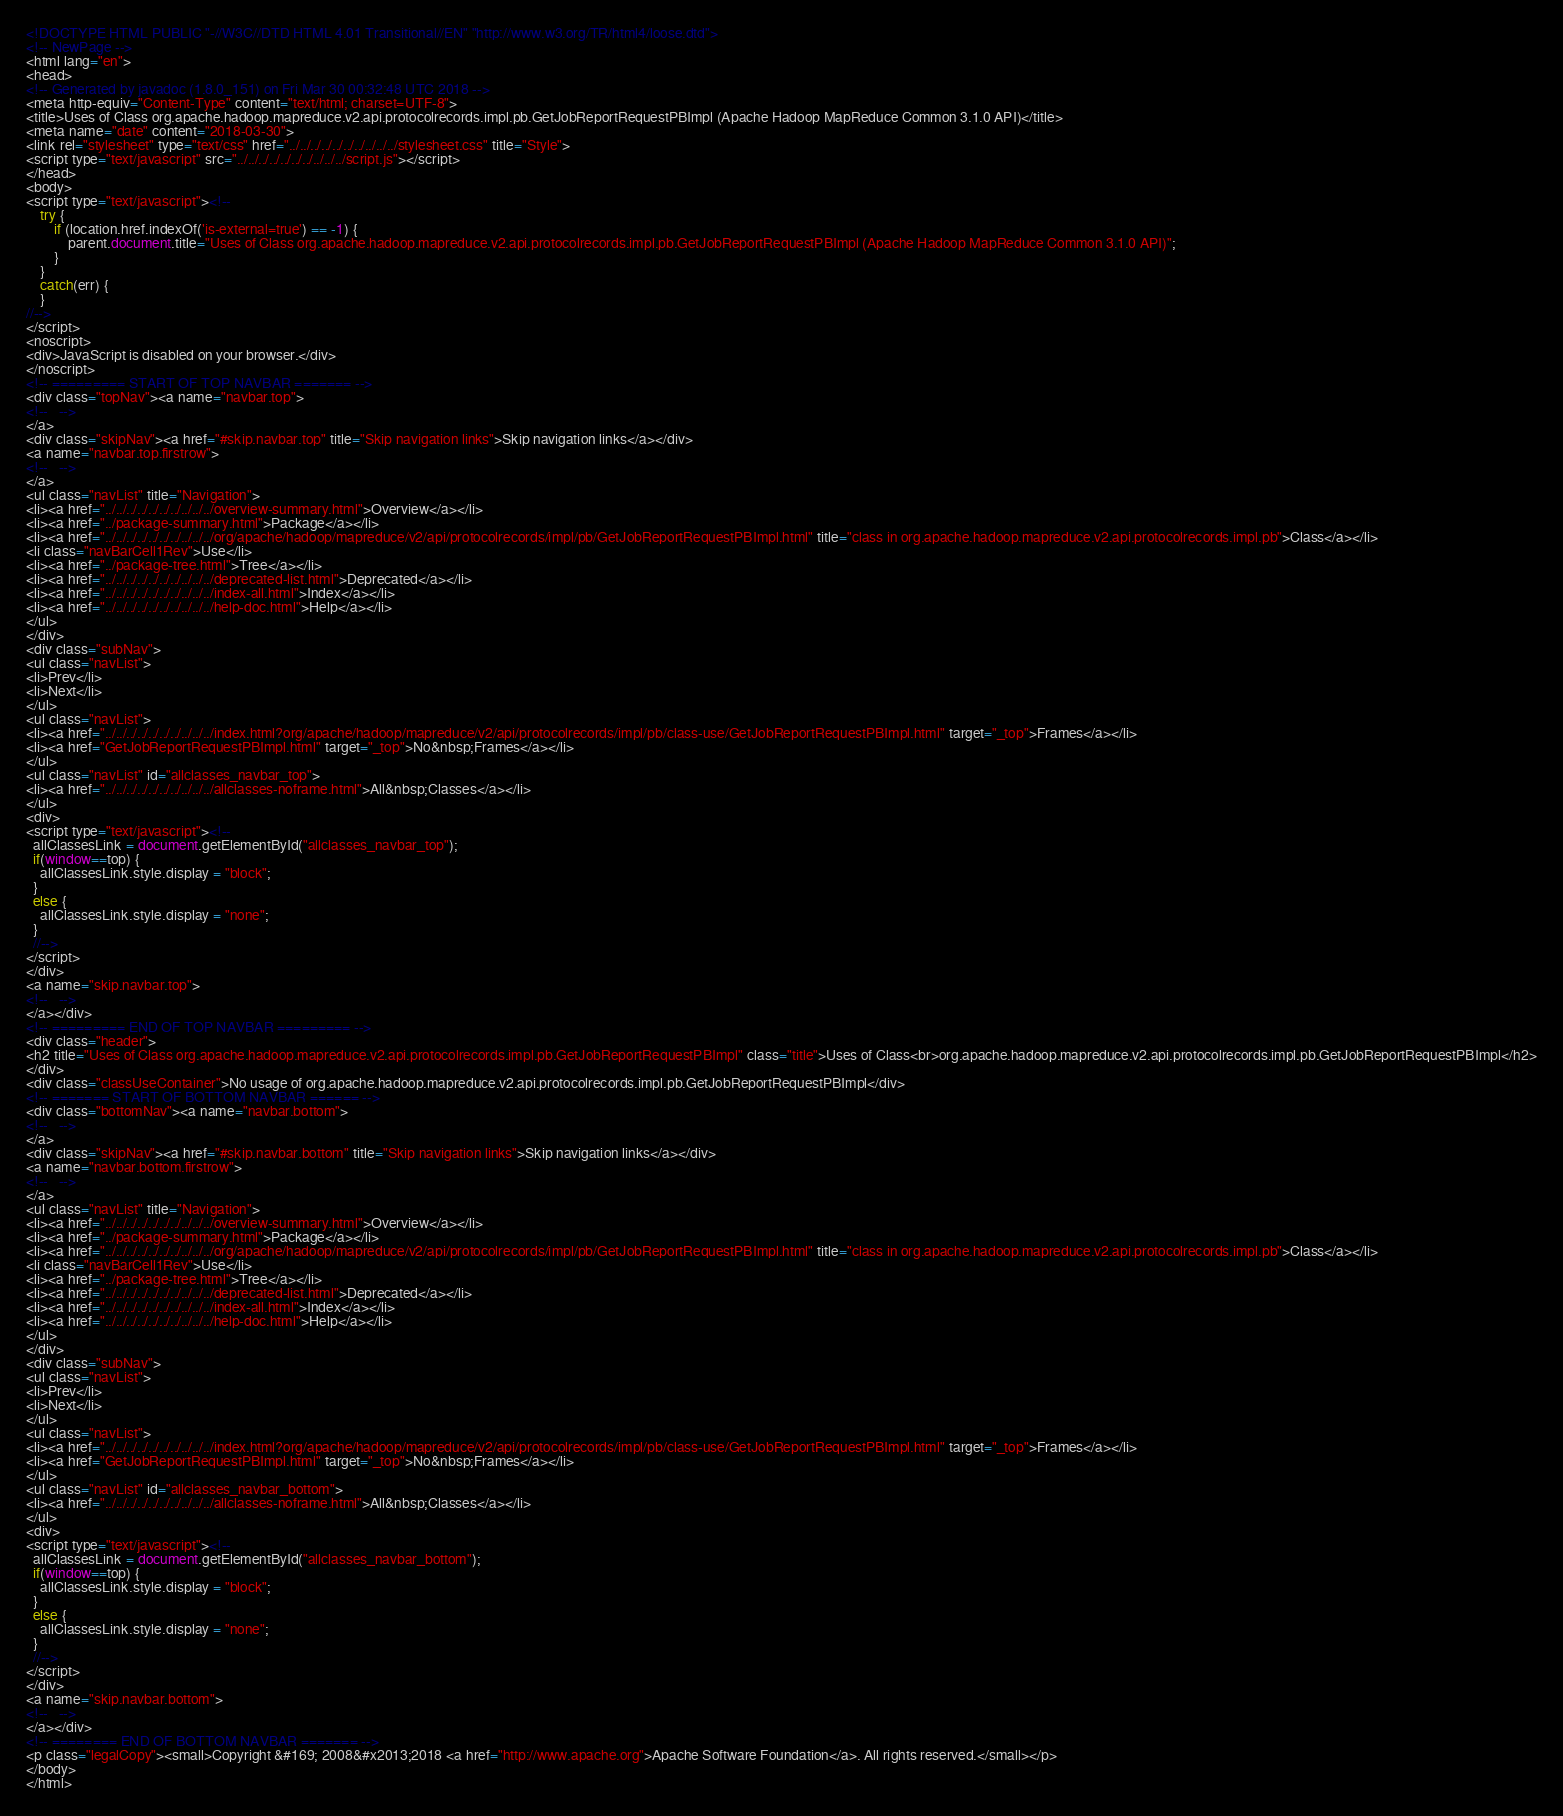Convert code to text. <code><loc_0><loc_0><loc_500><loc_500><_HTML_><!DOCTYPE HTML PUBLIC "-//W3C//DTD HTML 4.01 Transitional//EN" "http://www.w3.org/TR/html4/loose.dtd">
<!-- NewPage -->
<html lang="en">
<head>
<!-- Generated by javadoc (1.8.0_151) on Fri Mar 30 00:32:48 UTC 2018 -->
<meta http-equiv="Content-Type" content="text/html; charset=UTF-8">
<title>Uses of Class org.apache.hadoop.mapreduce.v2.api.protocolrecords.impl.pb.GetJobReportRequestPBImpl (Apache Hadoop MapReduce Common 3.1.0 API)</title>
<meta name="date" content="2018-03-30">
<link rel="stylesheet" type="text/css" href="../../../../../../../../../../stylesheet.css" title="Style">
<script type="text/javascript" src="../../../../../../../../../../script.js"></script>
</head>
<body>
<script type="text/javascript"><!--
    try {
        if (location.href.indexOf('is-external=true') == -1) {
            parent.document.title="Uses of Class org.apache.hadoop.mapreduce.v2.api.protocolrecords.impl.pb.GetJobReportRequestPBImpl (Apache Hadoop MapReduce Common 3.1.0 API)";
        }
    }
    catch(err) {
    }
//-->
</script>
<noscript>
<div>JavaScript is disabled on your browser.</div>
</noscript>
<!-- ========= START OF TOP NAVBAR ======= -->
<div class="topNav"><a name="navbar.top">
<!--   -->
</a>
<div class="skipNav"><a href="#skip.navbar.top" title="Skip navigation links">Skip navigation links</a></div>
<a name="navbar.top.firstrow">
<!--   -->
</a>
<ul class="navList" title="Navigation">
<li><a href="../../../../../../../../../../overview-summary.html">Overview</a></li>
<li><a href="../package-summary.html">Package</a></li>
<li><a href="../../../../../../../../../../org/apache/hadoop/mapreduce/v2/api/protocolrecords/impl/pb/GetJobReportRequestPBImpl.html" title="class in org.apache.hadoop.mapreduce.v2.api.protocolrecords.impl.pb">Class</a></li>
<li class="navBarCell1Rev">Use</li>
<li><a href="../package-tree.html">Tree</a></li>
<li><a href="../../../../../../../../../../deprecated-list.html">Deprecated</a></li>
<li><a href="../../../../../../../../../../index-all.html">Index</a></li>
<li><a href="../../../../../../../../../../help-doc.html">Help</a></li>
</ul>
</div>
<div class="subNav">
<ul class="navList">
<li>Prev</li>
<li>Next</li>
</ul>
<ul class="navList">
<li><a href="../../../../../../../../../../index.html?org/apache/hadoop/mapreduce/v2/api/protocolrecords/impl/pb/class-use/GetJobReportRequestPBImpl.html" target="_top">Frames</a></li>
<li><a href="GetJobReportRequestPBImpl.html" target="_top">No&nbsp;Frames</a></li>
</ul>
<ul class="navList" id="allclasses_navbar_top">
<li><a href="../../../../../../../../../../allclasses-noframe.html">All&nbsp;Classes</a></li>
</ul>
<div>
<script type="text/javascript"><!--
  allClassesLink = document.getElementById("allclasses_navbar_top");
  if(window==top) {
    allClassesLink.style.display = "block";
  }
  else {
    allClassesLink.style.display = "none";
  }
  //-->
</script>
</div>
<a name="skip.navbar.top">
<!--   -->
</a></div>
<!-- ========= END OF TOP NAVBAR ========= -->
<div class="header">
<h2 title="Uses of Class org.apache.hadoop.mapreduce.v2.api.protocolrecords.impl.pb.GetJobReportRequestPBImpl" class="title">Uses of Class<br>org.apache.hadoop.mapreduce.v2.api.protocolrecords.impl.pb.GetJobReportRequestPBImpl</h2>
</div>
<div class="classUseContainer">No usage of org.apache.hadoop.mapreduce.v2.api.protocolrecords.impl.pb.GetJobReportRequestPBImpl</div>
<!-- ======= START OF BOTTOM NAVBAR ====== -->
<div class="bottomNav"><a name="navbar.bottom">
<!--   -->
</a>
<div class="skipNav"><a href="#skip.navbar.bottom" title="Skip navigation links">Skip navigation links</a></div>
<a name="navbar.bottom.firstrow">
<!--   -->
</a>
<ul class="navList" title="Navigation">
<li><a href="../../../../../../../../../../overview-summary.html">Overview</a></li>
<li><a href="../package-summary.html">Package</a></li>
<li><a href="../../../../../../../../../../org/apache/hadoop/mapreduce/v2/api/protocolrecords/impl/pb/GetJobReportRequestPBImpl.html" title="class in org.apache.hadoop.mapreduce.v2.api.protocolrecords.impl.pb">Class</a></li>
<li class="navBarCell1Rev">Use</li>
<li><a href="../package-tree.html">Tree</a></li>
<li><a href="../../../../../../../../../../deprecated-list.html">Deprecated</a></li>
<li><a href="../../../../../../../../../../index-all.html">Index</a></li>
<li><a href="../../../../../../../../../../help-doc.html">Help</a></li>
</ul>
</div>
<div class="subNav">
<ul class="navList">
<li>Prev</li>
<li>Next</li>
</ul>
<ul class="navList">
<li><a href="../../../../../../../../../../index.html?org/apache/hadoop/mapreduce/v2/api/protocolrecords/impl/pb/class-use/GetJobReportRequestPBImpl.html" target="_top">Frames</a></li>
<li><a href="GetJobReportRequestPBImpl.html" target="_top">No&nbsp;Frames</a></li>
</ul>
<ul class="navList" id="allclasses_navbar_bottom">
<li><a href="../../../../../../../../../../allclasses-noframe.html">All&nbsp;Classes</a></li>
</ul>
<div>
<script type="text/javascript"><!--
  allClassesLink = document.getElementById("allclasses_navbar_bottom");
  if(window==top) {
    allClassesLink.style.display = "block";
  }
  else {
    allClassesLink.style.display = "none";
  }
  //-->
</script>
</div>
<a name="skip.navbar.bottom">
<!--   -->
</a></div>
<!-- ======== END OF BOTTOM NAVBAR ======= -->
<p class="legalCopy"><small>Copyright &#169; 2008&#x2013;2018 <a href="http://www.apache.org">Apache Software Foundation</a>. All rights reserved.</small></p>
</body>
</html>
</code> 